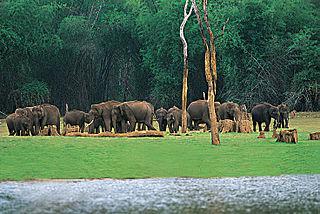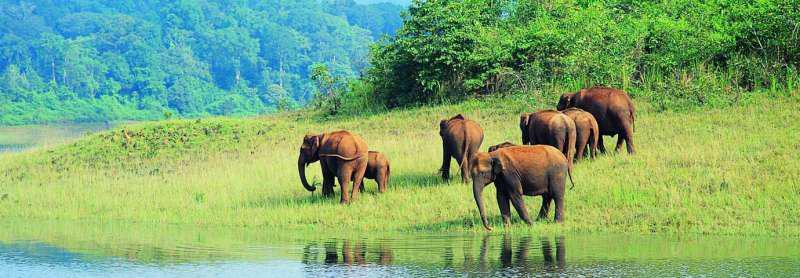The first image is the image on the left, the second image is the image on the right. For the images displayed, is the sentence "Some of the animals are near the water." factually correct? Answer yes or no. Yes. 